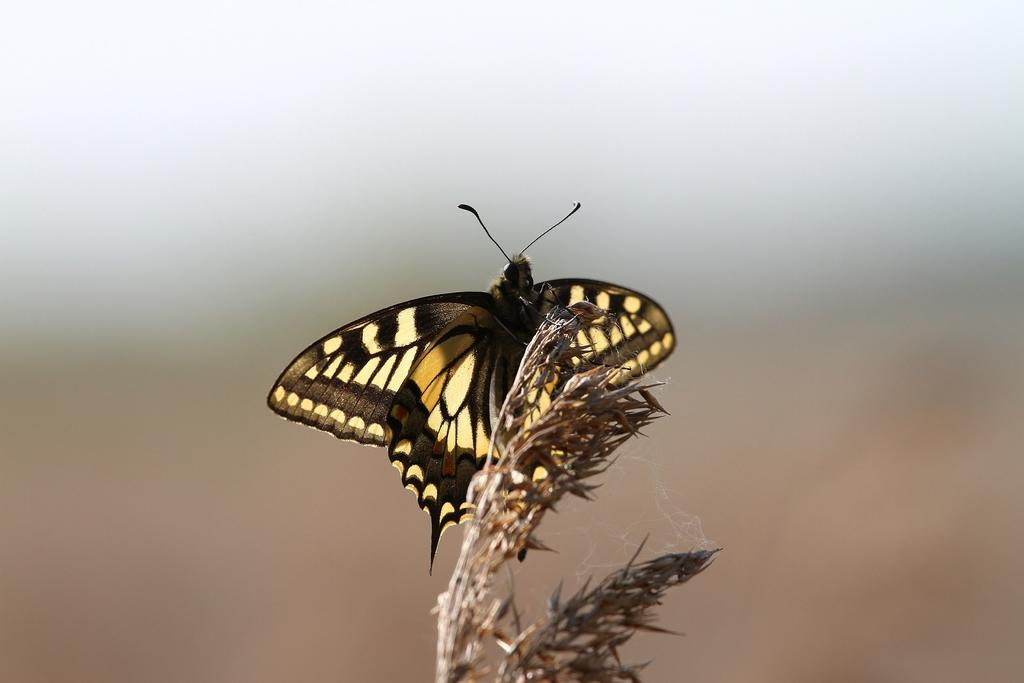What is the main subject of the image? The main subject of the image is a butterfly. Can you describe the colors of the butterfly? The butterfly is black and yellow in color. What is the butterfly resting on in the image? The butterfly is on an object. What type of thought is the butterfly expressing in the image? Butterflies do not express thoughts, as they are insects and do not have the cognitive ability to do so. 